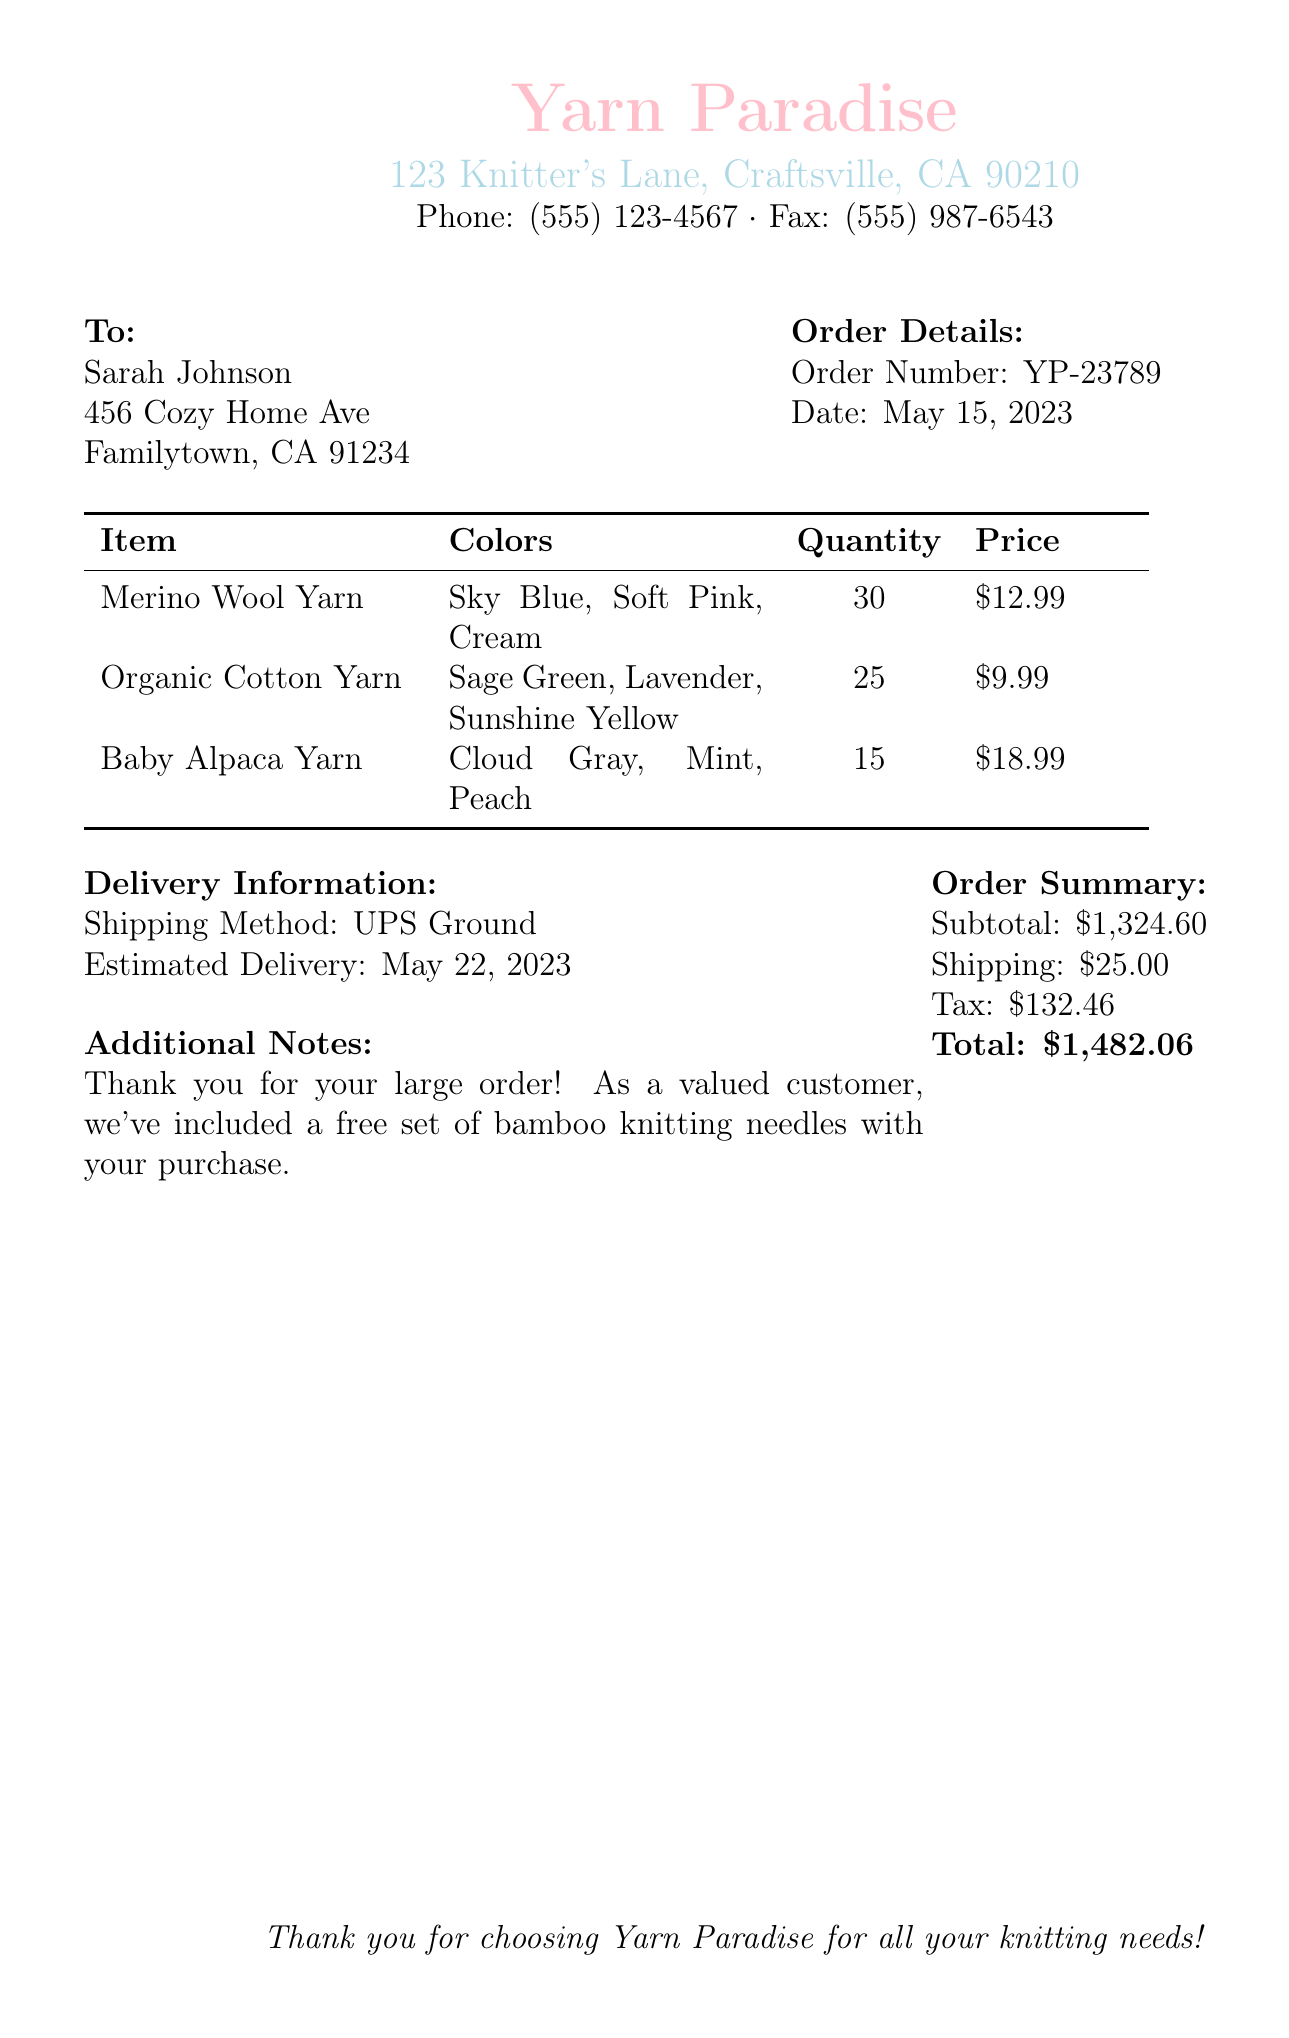What is the order number? The order number is listed under the order details section of the document as YP-23789.
Answer: YP-23789 Who is the recipient of the order? The recipient's name is mentioned at the top of the document, identified as Sarah Johnson.
Answer: Sarah Johnson What is the estimated delivery date? The estimated delivery date is indicated in the delivery information section of the document as May 22, 2023.
Answer: May 22, 2023 How many Baby Alpaca Yarn items were ordered? The quantity ordered for Baby Alpaca Yarn is provided in the order details table, which shows 15.
Answer: 15 What is the subtotal of the order? The subtotal is listed in the order summary as $1,324.60.
Answer: $1,324.60 What free item is included with the order? The document notes that a free set of bamboo knitting needles is included as a thank-you for the order.
Answer: Bamboo knitting needles What is the total amount due? The total amount due is summarized at the bottom of the order summary as $1,482.06.
Answer: $1,482.06 Which shipping method will be used? The shipping method is mentioned in the delivery information section as UPS Ground.
Answer: UPS Ground What are the colors of the Merino Wool Yarn? The colors for the Merino Wool Yarn are mentioned in the details table as Sky Blue, Soft Pink, and Cream.
Answer: Sky Blue, Soft Pink, Cream 